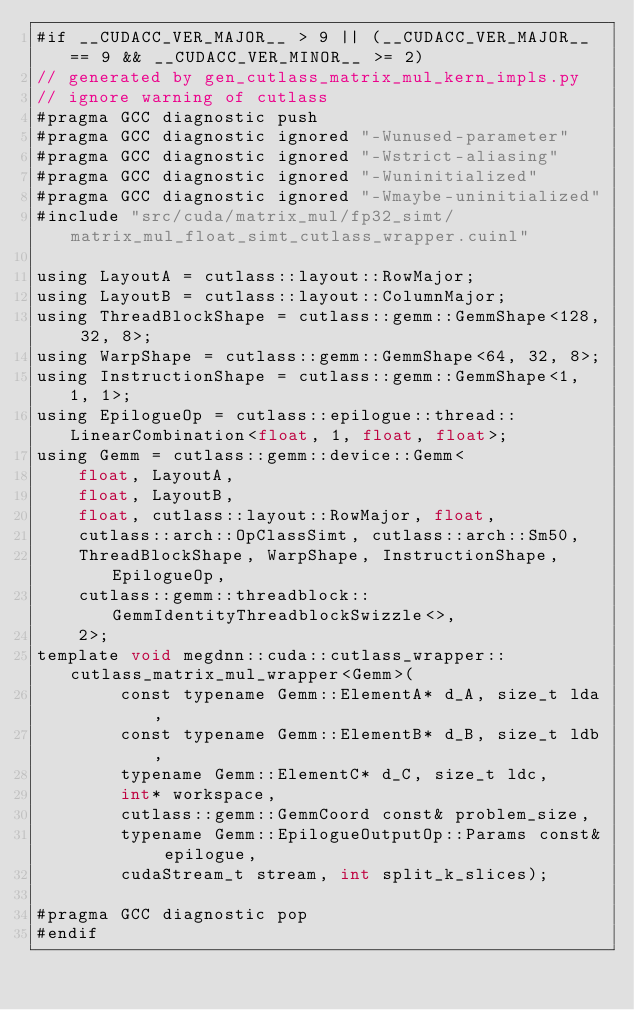Convert code to text. <code><loc_0><loc_0><loc_500><loc_500><_Cuda_>#if __CUDACC_VER_MAJOR__ > 9 || (__CUDACC_VER_MAJOR__ == 9 && __CUDACC_VER_MINOR__ >= 2)
// generated by gen_cutlass_matrix_mul_kern_impls.py
// ignore warning of cutlass
#pragma GCC diagnostic push
#pragma GCC diagnostic ignored "-Wunused-parameter"
#pragma GCC diagnostic ignored "-Wstrict-aliasing"
#pragma GCC diagnostic ignored "-Wuninitialized"
#pragma GCC diagnostic ignored "-Wmaybe-uninitialized"
#include "src/cuda/matrix_mul/fp32_simt/matrix_mul_float_simt_cutlass_wrapper.cuinl"

using LayoutA = cutlass::layout::RowMajor;
using LayoutB = cutlass::layout::ColumnMajor;
using ThreadBlockShape = cutlass::gemm::GemmShape<128, 32, 8>;
using WarpShape = cutlass::gemm::GemmShape<64, 32, 8>;
using InstructionShape = cutlass::gemm::GemmShape<1, 1, 1>;
using EpilogueOp = cutlass::epilogue::thread::LinearCombination<float, 1, float, float>;
using Gemm = cutlass::gemm::device::Gemm<
    float, LayoutA, 
    float, LayoutB, 
    float, cutlass::layout::RowMajor, float, 
    cutlass::arch::OpClassSimt, cutlass::arch::Sm50, 
    ThreadBlockShape, WarpShape, InstructionShape, EpilogueOp, 
    cutlass::gemm::threadblock::GemmIdentityThreadblockSwizzle<>, 
    2>;
template void megdnn::cuda::cutlass_wrapper::cutlass_matrix_mul_wrapper<Gemm>(
        const typename Gemm::ElementA* d_A, size_t lda, 
        const typename Gemm::ElementB* d_B, size_t ldb,  
        typename Gemm::ElementC* d_C, size_t ldc,  
        int* workspace, 
        cutlass::gemm::GemmCoord const& problem_size,   
        typename Gemm::EpilogueOutputOp::Params const& epilogue, 
        cudaStream_t stream, int split_k_slices);

#pragma GCC diagnostic pop
#endif
</code> 